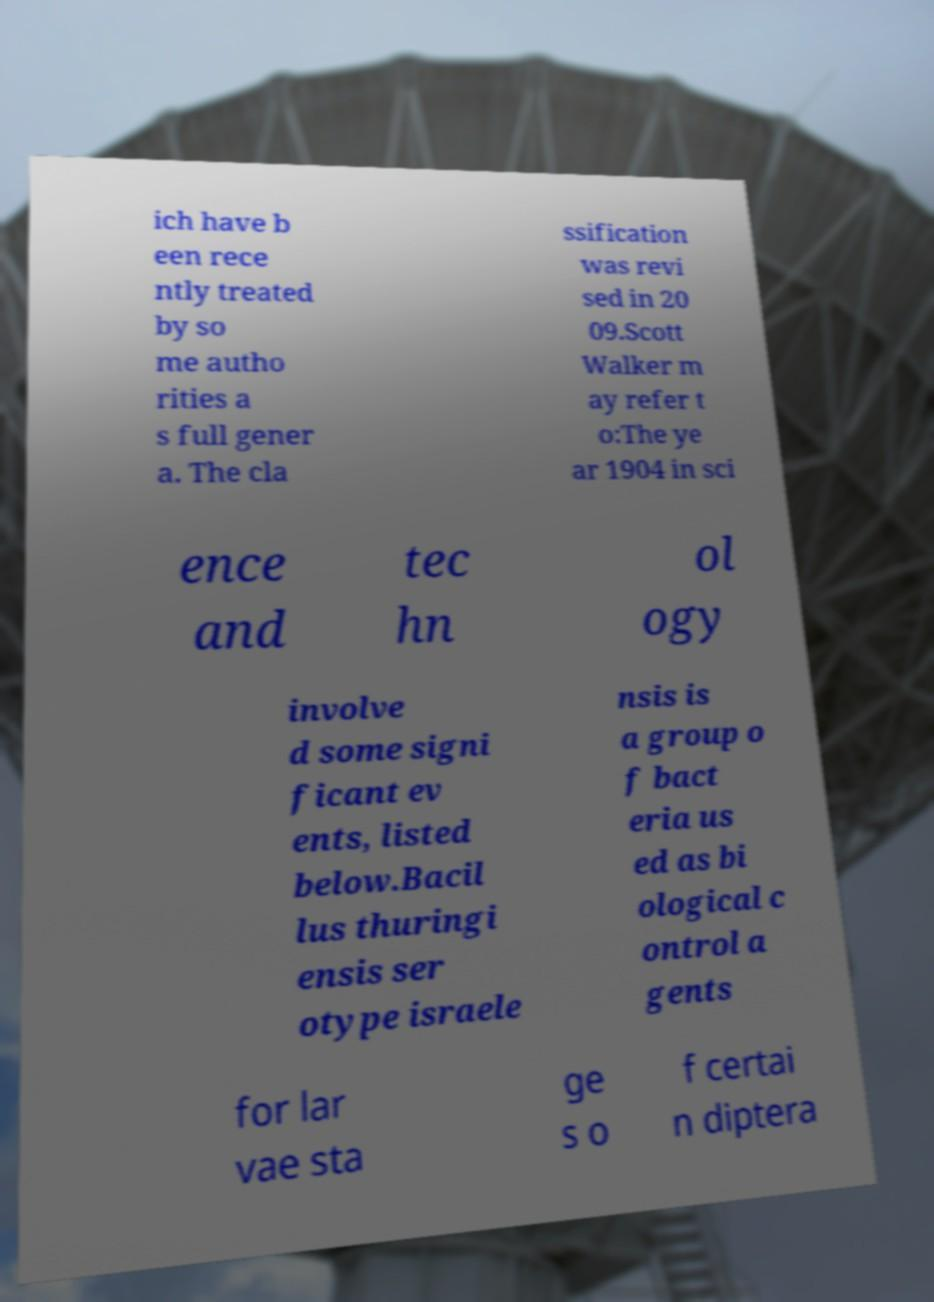Can you read and provide the text displayed in the image?This photo seems to have some interesting text. Can you extract and type it out for me? ich have b een rece ntly treated by so me autho rities a s full gener a. The cla ssification was revi sed in 20 09.Scott Walker m ay refer t o:The ye ar 1904 in sci ence and tec hn ol ogy involve d some signi ficant ev ents, listed below.Bacil lus thuringi ensis ser otype israele nsis is a group o f bact eria us ed as bi ological c ontrol a gents for lar vae sta ge s o f certai n diptera 